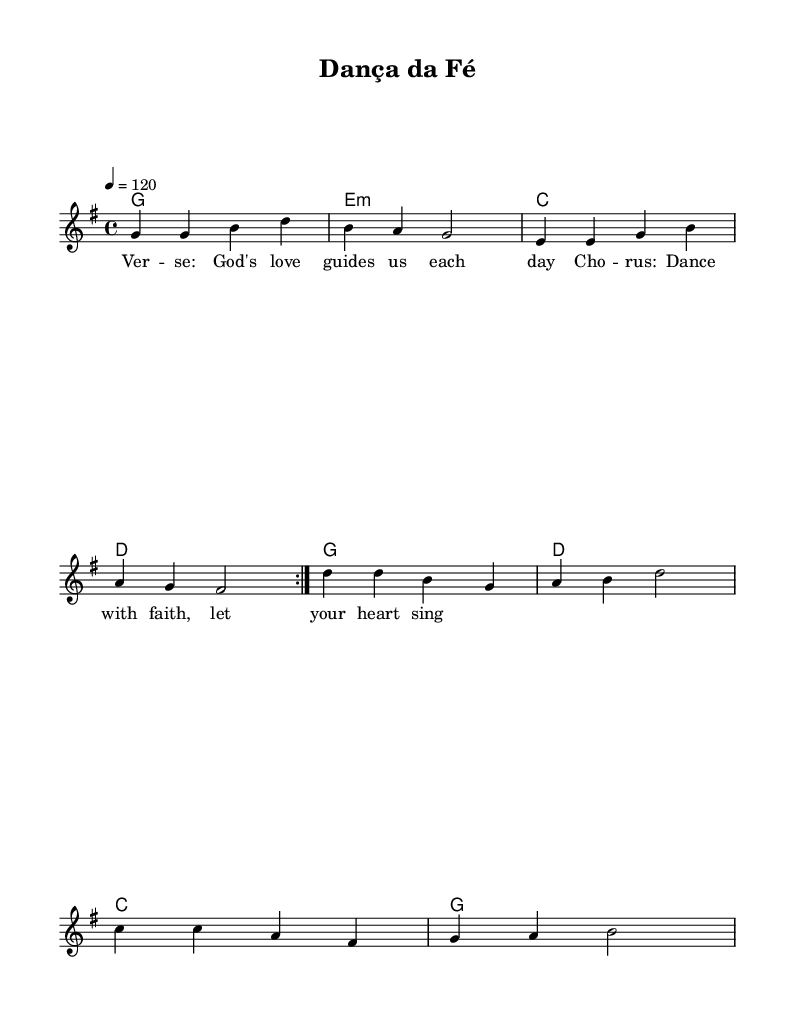What is the key signature of this music? The key signature is shown in the beginning of the score, indicating the presence of one sharp, F-sharp. Therefore, the key is G major.
Answer: G major What is the time signature of this music? The time signature is indicated at the beginning of the score, which shows a 4/4 time signature, meaning there are four beats in each measure.
Answer: 4/4 What is the tempo marking in this music? The tempo marking at the beginning indicates a speed of 120 beats per minute, specifying how fast the piece should be played.
Answer: 120 How many measures are in the melody section? To find the number of measures, we count all the measures in the melody line provided. There are a total of eight measures in the repeated section.
Answer: 8 What chord is played in the first measure of the harmony? The first chord in the harmony section is indicated as a G chord, which is established at the beginning of this section.
Answer: G What type of lyrical content is present in this music? The lyrics contain Christian themes, expressing love and guidance from God, in alignment with a positive, faith-based message suitable for contemporary dance music.
Answer: Faith-based What notable repetitions occur in this music piece? The score features a repeated section indicated by "volta" in the melody, signifying that the first part should be played again.
Answer: Volta 